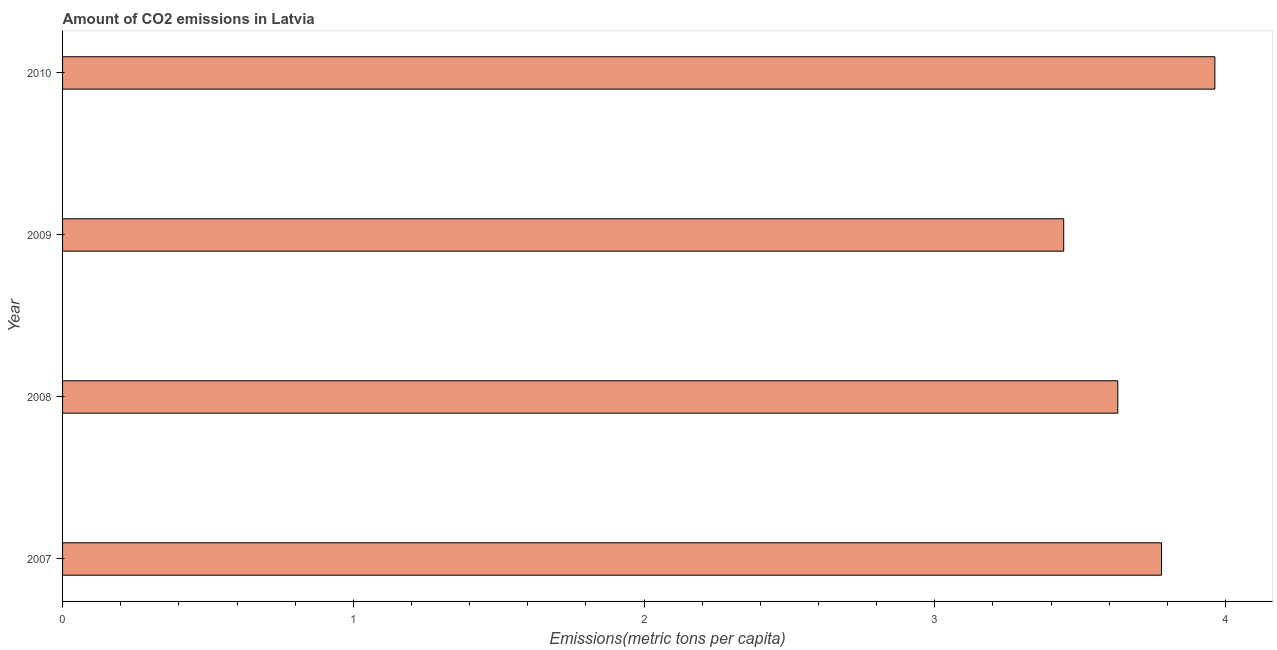Does the graph contain any zero values?
Provide a short and direct response. No. What is the title of the graph?
Provide a succinct answer. Amount of CO2 emissions in Latvia. What is the label or title of the X-axis?
Provide a succinct answer. Emissions(metric tons per capita). What is the label or title of the Y-axis?
Give a very brief answer. Year. What is the amount of co2 emissions in 2010?
Your response must be concise. 3.96. Across all years, what is the maximum amount of co2 emissions?
Your response must be concise. 3.96. Across all years, what is the minimum amount of co2 emissions?
Your answer should be very brief. 3.44. What is the sum of the amount of co2 emissions?
Your response must be concise. 14.82. What is the difference between the amount of co2 emissions in 2007 and 2010?
Offer a very short reply. -0.18. What is the average amount of co2 emissions per year?
Keep it short and to the point. 3.7. What is the median amount of co2 emissions?
Your answer should be very brief. 3.7. In how many years, is the amount of co2 emissions greater than 1.2 metric tons per capita?
Your answer should be compact. 4. What is the ratio of the amount of co2 emissions in 2007 to that in 2008?
Your answer should be very brief. 1.04. What is the difference between the highest and the second highest amount of co2 emissions?
Keep it short and to the point. 0.18. What is the difference between the highest and the lowest amount of co2 emissions?
Provide a short and direct response. 0.52. In how many years, is the amount of co2 emissions greater than the average amount of co2 emissions taken over all years?
Your answer should be very brief. 2. How many bars are there?
Your answer should be compact. 4. How many years are there in the graph?
Your answer should be compact. 4. What is the Emissions(metric tons per capita) of 2007?
Your answer should be very brief. 3.78. What is the Emissions(metric tons per capita) in 2008?
Make the answer very short. 3.63. What is the Emissions(metric tons per capita) of 2009?
Keep it short and to the point. 3.44. What is the Emissions(metric tons per capita) in 2010?
Provide a succinct answer. 3.96. What is the difference between the Emissions(metric tons per capita) in 2007 and 2008?
Offer a terse response. 0.15. What is the difference between the Emissions(metric tons per capita) in 2007 and 2009?
Your answer should be compact. 0.34. What is the difference between the Emissions(metric tons per capita) in 2007 and 2010?
Provide a short and direct response. -0.18. What is the difference between the Emissions(metric tons per capita) in 2008 and 2009?
Ensure brevity in your answer.  0.19. What is the difference between the Emissions(metric tons per capita) in 2008 and 2010?
Keep it short and to the point. -0.33. What is the difference between the Emissions(metric tons per capita) in 2009 and 2010?
Make the answer very short. -0.52. What is the ratio of the Emissions(metric tons per capita) in 2007 to that in 2008?
Ensure brevity in your answer.  1.04. What is the ratio of the Emissions(metric tons per capita) in 2007 to that in 2009?
Your answer should be very brief. 1.1. What is the ratio of the Emissions(metric tons per capita) in 2007 to that in 2010?
Your answer should be compact. 0.95. What is the ratio of the Emissions(metric tons per capita) in 2008 to that in 2009?
Give a very brief answer. 1.05. What is the ratio of the Emissions(metric tons per capita) in 2008 to that in 2010?
Your answer should be compact. 0.92. What is the ratio of the Emissions(metric tons per capita) in 2009 to that in 2010?
Ensure brevity in your answer.  0.87. 